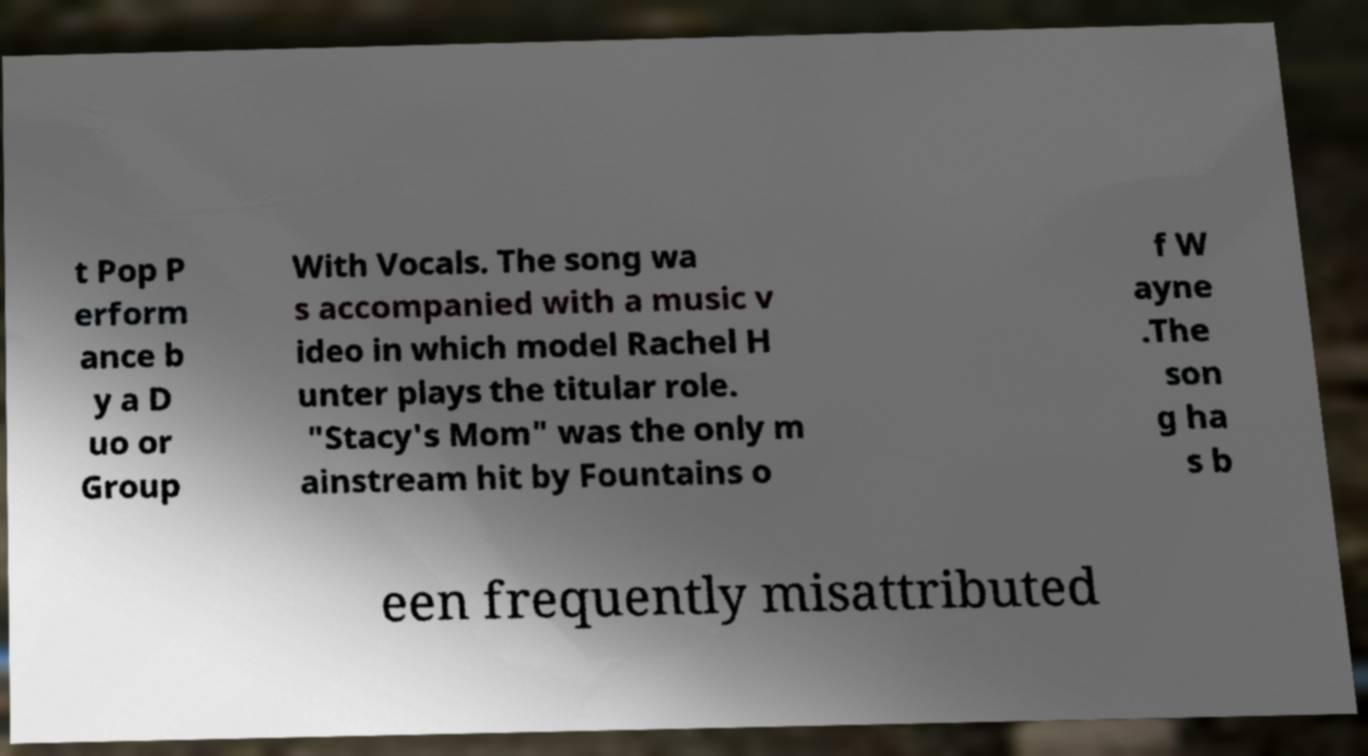Can you read and provide the text displayed in the image?This photo seems to have some interesting text. Can you extract and type it out for me? t Pop P erform ance b y a D uo or Group With Vocals. The song wa s accompanied with a music v ideo in which model Rachel H unter plays the titular role. "Stacy's Mom" was the only m ainstream hit by Fountains o f W ayne .The son g ha s b een frequently misattributed 